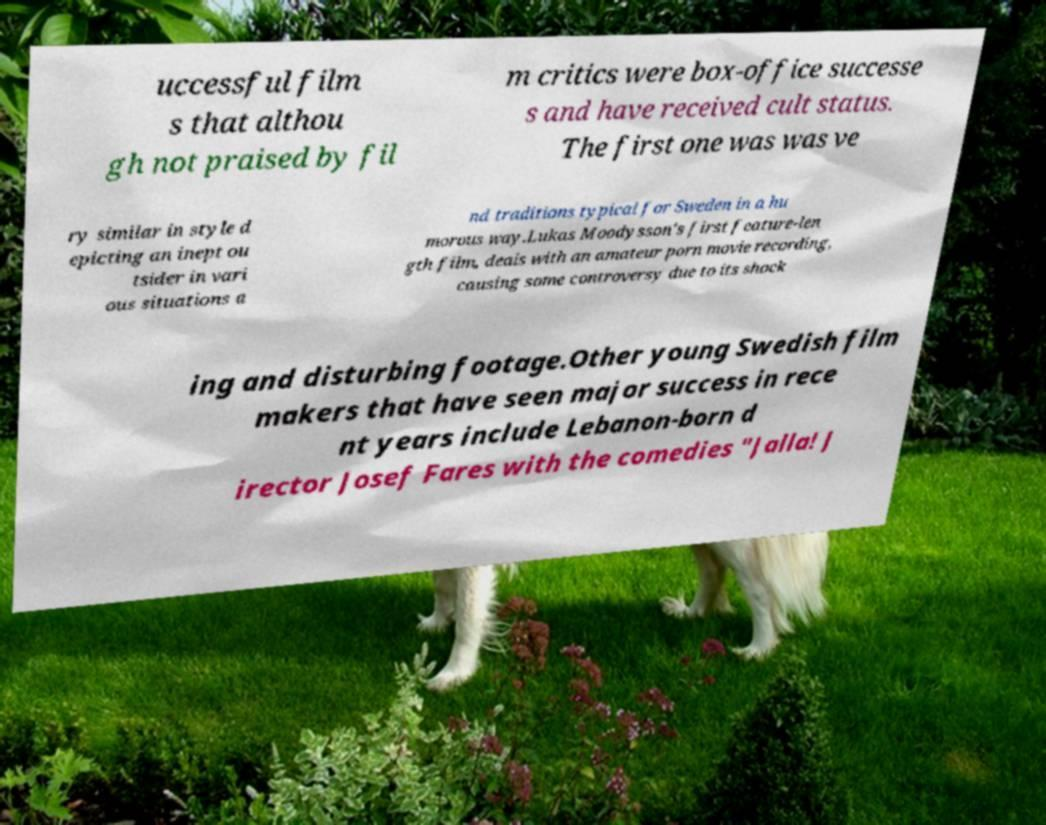What messages or text are displayed in this image? I need them in a readable, typed format. uccessful film s that althou gh not praised by fil m critics were box-office successe s and have received cult status. The first one was was ve ry similar in style d epicting an inept ou tsider in vari ous situations a nd traditions typical for Sweden in a hu morous way.Lukas Moodysson's first feature-len gth film, deals with an amateur porn movie recording, causing some controversy due to its shock ing and disturbing footage.Other young Swedish film makers that have seen major success in rece nt years include Lebanon-born d irector Josef Fares with the comedies "Jalla! J 